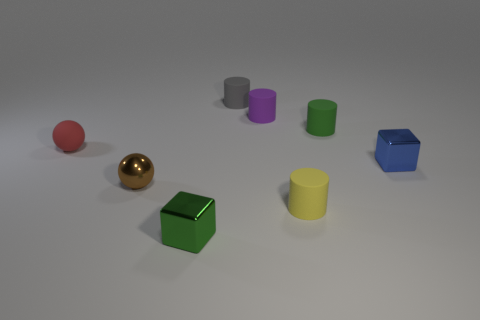Subtract all small purple cylinders. How many cylinders are left? 3 Subtract all green cylinders. How many cylinders are left? 3 Add 1 red objects. How many objects exist? 9 Subtract all brown balls. How many yellow cylinders are left? 1 Subtract all purple cubes. Subtract all purple matte things. How many objects are left? 7 Add 3 green shiny things. How many green shiny things are left? 4 Add 7 tiny yellow rubber things. How many tiny yellow rubber things exist? 8 Subtract 0 green balls. How many objects are left? 8 Subtract all blocks. How many objects are left? 6 Subtract 1 spheres. How many spheres are left? 1 